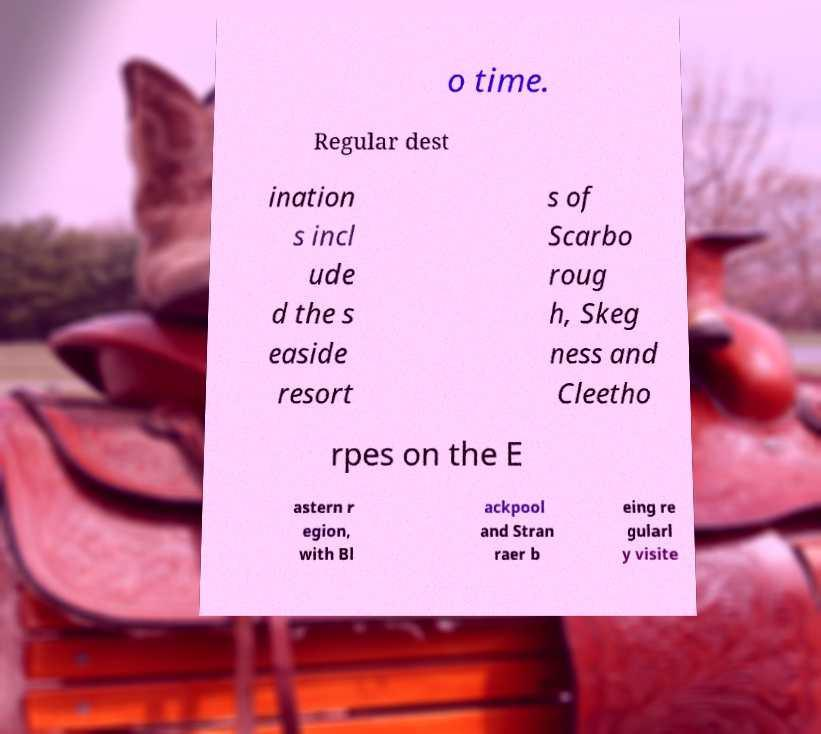Could you extract and type out the text from this image? o time. Regular dest ination s incl ude d the s easide resort s of Scarbo roug h, Skeg ness and Cleetho rpes on the E astern r egion, with Bl ackpool and Stran raer b eing re gularl y visite 